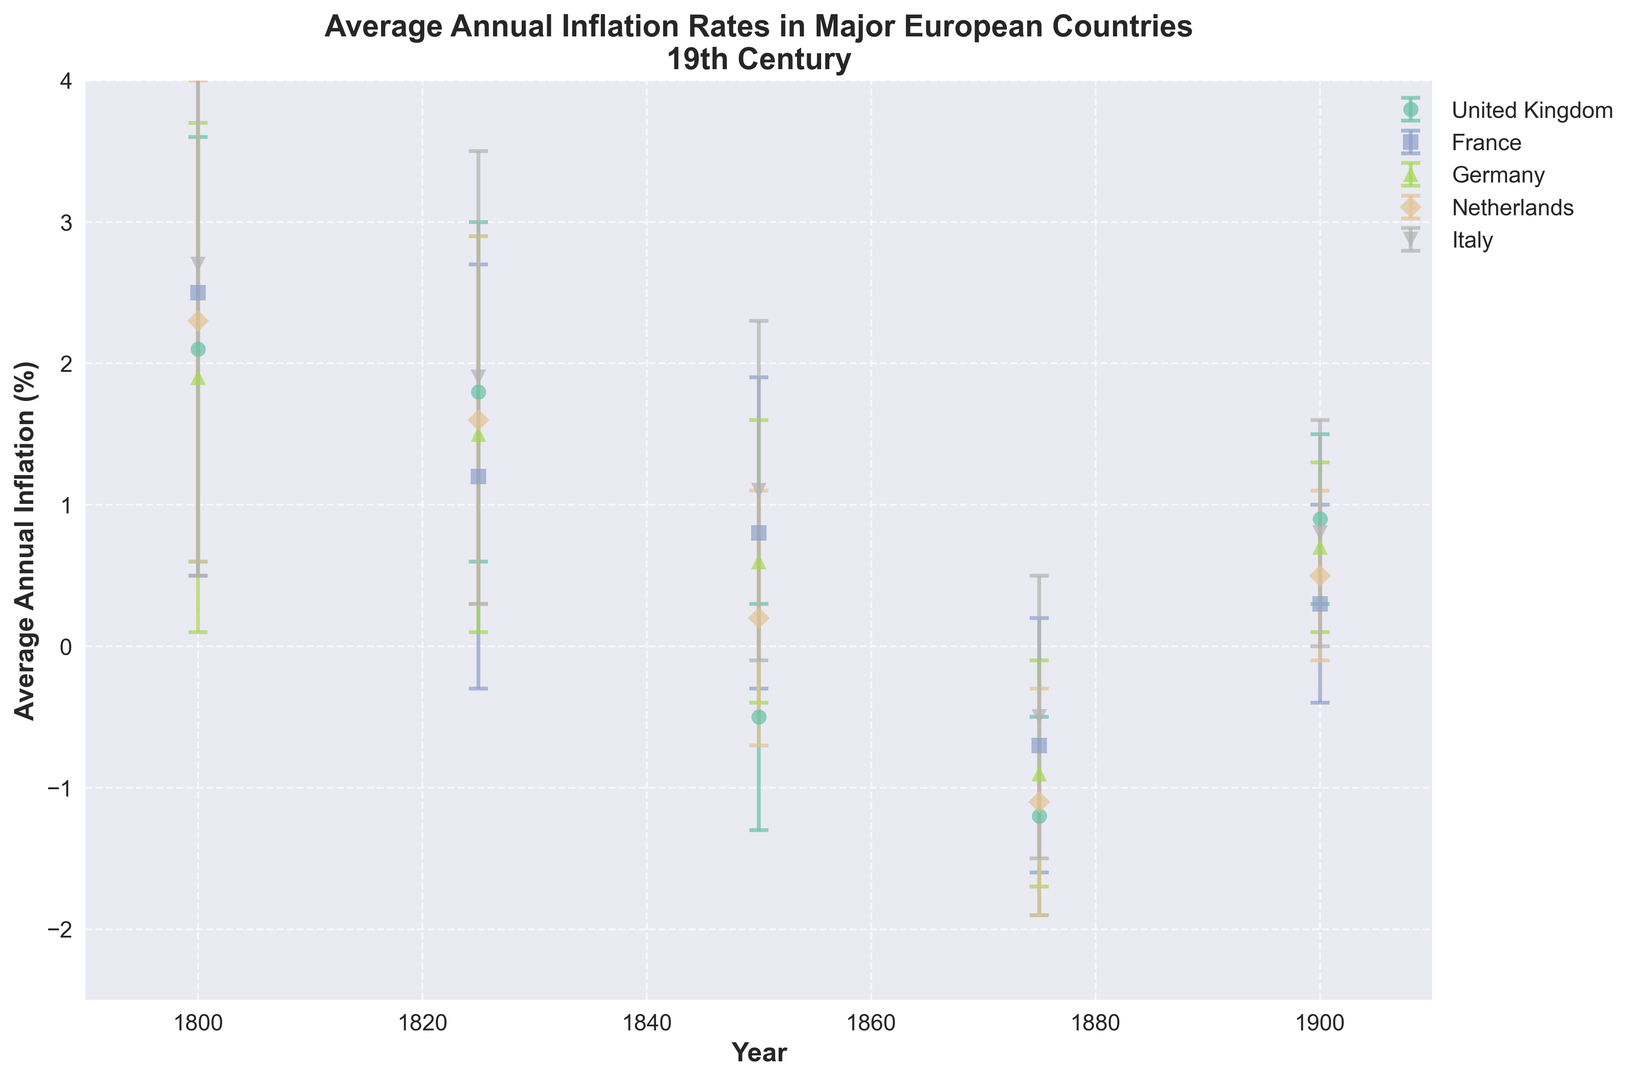What is the average annual inflation rate in Italy around the year 1800? To find the average annual inflation rate for Italy in 1800, you look at the plot and locate the data point for Italy at the year 1800. The value is 2.7%.
Answer: 2.7% Which country had the highest average annual inflation rate in the year 1850? To determine the highest inflation rate in 1850, compare all the countries' inflation rates for that year. Italy had the highest value at 1.1%.
Answer: Italy During which year did the United Kingdom experience the lowest average annual inflation rate, and what was the value? Inspect the inflation data points along the UK’s trend line to find the lowest point. The United Kingdom had its lowest inflation rate in 1875 at -1.2%.
Answer: 1875, -1.2% Comparing the years 1800 and 1900, which country showed the greatest decrease in average annual inflation rates? Subtract the inflation rate in 1900 from 1800 for all countries and compare the differences. The United Kingdom had the largest decrease from 2.1% in 1800 to 0.9% in 1900, resulting in a decrease of 1.2%.
Answer: United Kingdom What is the overall range of average annual inflation rates for France throughout the 19th century? To find the range, identify the maximum and minimum inflation rates for France. The highest rate is 2.5% (1800) and the lowest is -0.7% (1875). The range is 2.5% - (-0.7%) = 3.2%.
Answer: 3.2% Which country had the least economic volatility (smallest average error bar) in the year 1875? Compare the size of the error bars for all countries in 1875. The United Kingdom shows the smallest error bar of 0.7.
Answer: United Kingdom Among the listed countries, which one maintained the most consistent (least volatile) inflation rate over the 19th century? Calculate the average error bar for each country across all years and determine which is smallest. The country with the lowest average error bar is the United Kingdom.
Answer: United Kingdom 